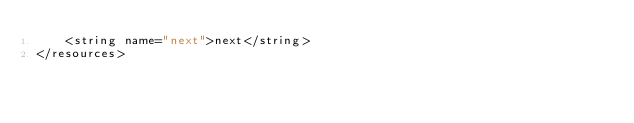<code> <loc_0><loc_0><loc_500><loc_500><_XML_>    <string name="next">next</string>
</resources></code> 